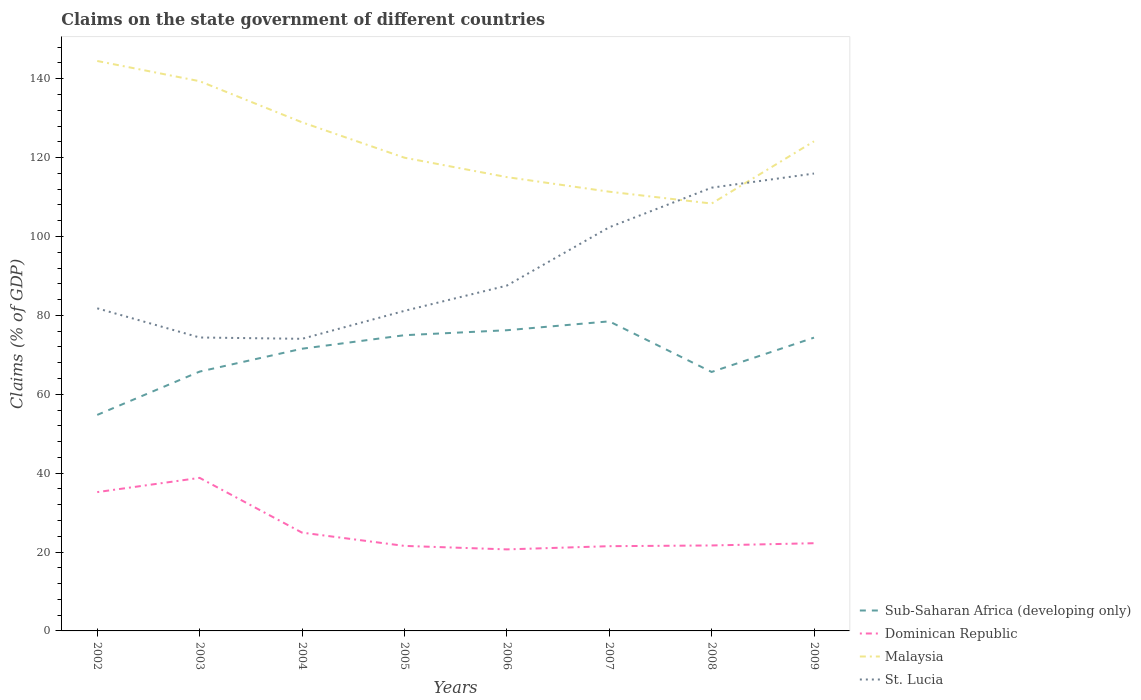Across all years, what is the maximum percentage of GDP claimed on the state government in St. Lucia?
Ensure brevity in your answer.  74.05. What is the total percentage of GDP claimed on the state government in Dominican Republic in the graph?
Give a very brief answer. 17.13. What is the difference between the highest and the second highest percentage of GDP claimed on the state government in Dominican Republic?
Offer a very short reply. 18.13. Is the percentage of GDP claimed on the state government in Sub-Saharan Africa (developing only) strictly greater than the percentage of GDP claimed on the state government in Dominican Republic over the years?
Provide a short and direct response. No. How many years are there in the graph?
Your answer should be compact. 8. Does the graph contain any zero values?
Give a very brief answer. No. Does the graph contain grids?
Your answer should be compact. No. Where does the legend appear in the graph?
Offer a terse response. Bottom right. How many legend labels are there?
Your answer should be compact. 4. What is the title of the graph?
Your answer should be very brief. Claims on the state government of different countries. What is the label or title of the X-axis?
Ensure brevity in your answer.  Years. What is the label or title of the Y-axis?
Make the answer very short. Claims (% of GDP). What is the Claims (% of GDP) in Sub-Saharan Africa (developing only) in 2002?
Your response must be concise. 54.76. What is the Claims (% of GDP) in Dominican Republic in 2002?
Give a very brief answer. 35.19. What is the Claims (% of GDP) in Malaysia in 2002?
Give a very brief answer. 144.49. What is the Claims (% of GDP) in St. Lucia in 2002?
Keep it short and to the point. 81.79. What is the Claims (% of GDP) in Sub-Saharan Africa (developing only) in 2003?
Provide a succinct answer. 65.75. What is the Claims (% of GDP) of Dominican Republic in 2003?
Ensure brevity in your answer.  38.8. What is the Claims (% of GDP) in Malaysia in 2003?
Offer a terse response. 139.37. What is the Claims (% of GDP) in St. Lucia in 2003?
Your answer should be very brief. 74.39. What is the Claims (% of GDP) of Sub-Saharan Africa (developing only) in 2004?
Your response must be concise. 71.54. What is the Claims (% of GDP) in Dominican Republic in 2004?
Ensure brevity in your answer.  24.92. What is the Claims (% of GDP) of Malaysia in 2004?
Make the answer very short. 128.94. What is the Claims (% of GDP) of St. Lucia in 2004?
Offer a very short reply. 74.05. What is the Claims (% of GDP) of Sub-Saharan Africa (developing only) in 2005?
Ensure brevity in your answer.  74.97. What is the Claims (% of GDP) of Dominican Republic in 2005?
Your answer should be compact. 21.56. What is the Claims (% of GDP) of Malaysia in 2005?
Provide a succinct answer. 119.97. What is the Claims (% of GDP) of St. Lucia in 2005?
Offer a very short reply. 81.14. What is the Claims (% of GDP) in Sub-Saharan Africa (developing only) in 2006?
Your answer should be compact. 76.23. What is the Claims (% of GDP) of Dominican Republic in 2006?
Provide a short and direct response. 20.67. What is the Claims (% of GDP) of Malaysia in 2006?
Make the answer very short. 115.05. What is the Claims (% of GDP) in St. Lucia in 2006?
Offer a terse response. 87.54. What is the Claims (% of GDP) in Sub-Saharan Africa (developing only) in 2007?
Give a very brief answer. 78.48. What is the Claims (% of GDP) in Dominican Republic in 2007?
Your answer should be very brief. 21.48. What is the Claims (% of GDP) in Malaysia in 2007?
Give a very brief answer. 111.35. What is the Claims (% of GDP) in St. Lucia in 2007?
Offer a terse response. 102.33. What is the Claims (% of GDP) in Sub-Saharan Africa (developing only) in 2008?
Offer a very short reply. 65.65. What is the Claims (% of GDP) of Dominican Republic in 2008?
Provide a short and direct response. 21.67. What is the Claims (% of GDP) of Malaysia in 2008?
Give a very brief answer. 108.35. What is the Claims (% of GDP) in St. Lucia in 2008?
Your response must be concise. 112.37. What is the Claims (% of GDP) of Sub-Saharan Africa (developing only) in 2009?
Keep it short and to the point. 74.35. What is the Claims (% of GDP) of Dominican Republic in 2009?
Keep it short and to the point. 22.24. What is the Claims (% of GDP) in Malaysia in 2009?
Provide a short and direct response. 124.12. What is the Claims (% of GDP) of St. Lucia in 2009?
Offer a very short reply. 115.96. Across all years, what is the maximum Claims (% of GDP) in Sub-Saharan Africa (developing only)?
Offer a terse response. 78.48. Across all years, what is the maximum Claims (% of GDP) of Dominican Republic?
Keep it short and to the point. 38.8. Across all years, what is the maximum Claims (% of GDP) in Malaysia?
Give a very brief answer. 144.49. Across all years, what is the maximum Claims (% of GDP) of St. Lucia?
Ensure brevity in your answer.  115.96. Across all years, what is the minimum Claims (% of GDP) in Sub-Saharan Africa (developing only)?
Offer a very short reply. 54.76. Across all years, what is the minimum Claims (% of GDP) of Dominican Republic?
Make the answer very short. 20.67. Across all years, what is the minimum Claims (% of GDP) in Malaysia?
Your answer should be very brief. 108.35. Across all years, what is the minimum Claims (% of GDP) of St. Lucia?
Provide a short and direct response. 74.05. What is the total Claims (% of GDP) in Sub-Saharan Africa (developing only) in the graph?
Your answer should be compact. 561.74. What is the total Claims (% of GDP) of Dominican Republic in the graph?
Your response must be concise. 206.52. What is the total Claims (% of GDP) in Malaysia in the graph?
Your response must be concise. 991.65. What is the total Claims (% of GDP) of St. Lucia in the graph?
Your answer should be very brief. 729.57. What is the difference between the Claims (% of GDP) in Sub-Saharan Africa (developing only) in 2002 and that in 2003?
Keep it short and to the point. -10.98. What is the difference between the Claims (% of GDP) of Dominican Republic in 2002 and that in 2003?
Offer a very short reply. -3.61. What is the difference between the Claims (% of GDP) of Malaysia in 2002 and that in 2003?
Your answer should be very brief. 5.12. What is the difference between the Claims (% of GDP) of St. Lucia in 2002 and that in 2003?
Offer a terse response. 7.4. What is the difference between the Claims (% of GDP) in Sub-Saharan Africa (developing only) in 2002 and that in 2004?
Keep it short and to the point. -16.78. What is the difference between the Claims (% of GDP) in Dominican Republic in 2002 and that in 2004?
Provide a succinct answer. 10.27. What is the difference between the Claims (% of GDP) of Malaysia in 2002 and that in 2004?
Your answer should be very brief. 15.54. What is the difference between the Claims (% of GDP) in St. Lucia in 2002 and that in 2004?
Provide a succinct answer. 7.73. What is the difference between the Claims (% of GDP) in Sub-Saharan Africa (developing only) in 2002 and that in 2005?
Keep it short and to the point. -20.21. What is the difference between the Claims (% of GDP) in Dominican Republic in 2002 and that in 2005?
Your answer should be compact. 13.64. What is the difference between the Claims (% of GDP) of Malaysia in 2002 and that in 2005?
Offer a very short reply. 24.52. What is the difference between the Claims (% of GDP) of St. Lucia in 2002 and that in 2005?
Provide a succinct answer. 0.64. What is the difference between the Claims (% of GDP) in Sub-Saharan Africa (developing only) in 2002 and that in 2006?
Offer a terse response. -21.47. What is the difference between the Claims (% of GDP) in Dominican Republic in 2002 and that in 2006?
Make the answer very short. 14.52. What is the difference between the Claims (% of GDP) of Malaysia in 2002 and that in 2006?
Offer a very short reply. 29.44. What is the difference between the Claims (% of GDP) in St. Lucia in 2002 and that in 2006?
Ensure brevity in your answer.  -5.76. What is the difference between the Claims (% of GDP) in Sub-Saharan Africa (developing only) in 2002 and that in 2007?
Provide a succinct answer. -23.72. What is the difference between the Claims (% of GDP) in Dominican Republic in 2002 and that in 2007?
Your answer should be very brief. 13.71. What is the difference between the Claims (% of GDP) in Malaysia in 2002 and that in 2007?
Your answer should be very brief. 33.13. What is the difference between the Claims (% of GDP) of St. Lucia in 2002 and that in 2007?
Provide a short and direct response. -20.54. What is the difference between the Claims (% of GDP) of Sub-Saharan Africa (developing only) in 2002 and that in 2008?
Your answer should be compact. -10.89. What is the difference between the Claims (% of GDP) in Dominican Republic in 2002 and that in 2008?
Your answer should be compact. 13.52. What is the difference between the Claims (% of GDP) in Malaysia in 2002 and that in 2008?
Provide a succinct answer. 36.14. What is the difference between the Claims (% of GDP) of St. Lucia in 2002 and that in 2008?
Keep it short and to the point. -30.58. What is the difference between the Claims (% of GDP) in Sub-Saharan Africa (developing only) in 2002 and that in 2009?
Give a very brief answer. -19.59. What is the difference between the Claims (% of GDP) of Dominican Republic in 2002 and that in 2009?
Give a very brief answer. 12.96. What is the difference between the Claims (% of GDP) in Malaysia in 2002 and that in 2009?
Give a very brief answer. 20.36. What is the difference between the Claims (% of GDP) in St. Lucia in 2002 and that in 2009?
Give a very brief answer. -34.17. What is the difference between the Claims (% of GDP) of Sub-Saharan Africa (developing only) in 2003 and that in 2004?
Provide a succinct answer. -5.8. What is the difference between the Claims (% of GDP) in Dominican Republic in 2003 and that in 2004?
Ensure brevity in your answer.  13.88. What is the difference between the Claims (% of GDP) of Malaysia in 2003 and that in 2004?
Give a very brief answer. 10.42. What is the difference between the Claims (% of GDP) in St. Lucia in 2003 and that in 2004?
Ensure brevity in your answer.  0.34. What is the difference between the Claims (% of GDP) in Sub-Saharan Africa (developing only) in 2003 and that in 2005?
Your answer should be very brief. -9.22. What is the difference between the Claims (% of GDP) of Dominican Republic in 2003 and that in 2005?
Your answer should be compact. 17.25. What is the difference between the Claims (% of GDP) in Malaysia in 2003 and that in 2005?
Your answer should be compact. 19.39. What is the difference between the Claims (% of GDP) of St. Lucia in 2003 and that in 2005?
Offer a very short reply. -6.75. What is the difference between the Claims (% of GDP) of Sub-Saharan Africa (developing only) in 2003 and that in 2006?
Offer a very short reply. -10.49. What is the difference between the Claims (% of GDP) in Dominican Republic in 2003 and that in 2006?
Your answer should be compact. 18.13. What is the difference between the Claims (% of GDP) of Malaysia in 2003 and that in 2006?
Give a very brief answer. 24.31. What is the difference between the Claims (% of GDP) in St. Lucia in 2003 and that in 2006?
Keep it short and to the point. -13.15. What is the difference between the Claims (% of GDP) of Sub-Saharan Africa (developing only) in 2003 and that in 2007?
Your response must be concise. -12.74. What is the difference between the Claims (% of GDP) of Dominican Republic in 2003 and that in 2007?
Provide a succinct answer. 17.32. What is the difference between the Claims (% of GDP) in Malaysia in 2003 and that in 2007?
Give a very brief answer. 28.01. What is the difference between the Claims (% of GDP) of St. Lucia in 2003 and that in 2007?
Ensure brevity in your answer.  -27.94. What is the difference between the Claims (% of GDP) in Sub-Saharan Africa (developing only) in 2003 and that in 2008?
Keep it short and to the point. 0.09. What is the difference between the Claims (% of GDP) of Dominican Republic in 2003 and that in 2008?
Ensure brevity in your answer.  17.13. What is the difference between the Claims (% of GDP) in Malaysia in 2003 and that in 2008?
Provide a succinct answer. 31.02. What is the difference between the Claims (% of GDP) of St. Lucia in 2003 and that in 2008?
Ensure brevity in your answer.  -37.98. What is the difference between the Claims (% of GDP) of Sub-Saharan Africa (developing only) in 2003 and that in 2009?
Your response must be concise. -8.61. What is the difference between the Claims (% of GDP) of Dominican Republic in 2003 and that in 2009?
Provide a short and direct response. 16.57. What is the difference between the Claims (% of GDP) in Malaysia in 2003 and that in 2009?
Provide a succinct answer. 15.24. What is the difference between the Claims (% of GDP) in St. Lucia in 2003 and that in 2009?
Provide a succinct answer. -41.56. What is the difference between the Claims (% of GDP) in Sub-Saharan Africa (developing only) in 2004 and that in 2005?
Offer a terse response. -3.43. What is the difference between the Claims (% of GDP) in Dominican Republic in 2004 and that in 2005?
Offer a terse response. 3.36. What is the difference between the Claims (% of GDP) in Malaysia in 2004 and that in 2005?
Your answer should be compact. 8.97. What is the difference between the Claims (% of GDP) in St. Lucia in 2004 and that in 2005?
Ensure brevity in your answer.  -7.09. What is the difference between the Claims (% of GDP) in Sub-Saharan Africa (developing only) in 2004 and that in 2006?
Keep it short and to the point. -4.69. What is the difference between the Claims (% of GDP) of Dominican Republic in 2004 and that in 2006?
Provide a short and direct response. 4.25. What is the difference between the Claims (% of GDP) of Malaysia in 2004 and that in 2006?
Make the answer very short. 13.89. What is the difference between the Claims (% of GDP) of St. Lucia in 2004 and that in 2006?
Ensure brevity in your answer.  -13.49. What is the difference between the Claims (% of GDP) of Sub-Saharan Africa (developing only) in 2004 and that in 2007?
Your answer should be very brief. -6.94. What is the difference between the Claims (% of GDP) in Dominican Republic in 2004 and that in 2007?
Provide a short and direct response. 3.44. What is the difference between the Claims (% of GDP) in Malaysia in 2004 and that in 2007?
Your answer should be very brief. 17.59. What is the difference between the Claims (% of GDP) in St. Lucia in 2004 and that in 2007?
Offer a terse response. -28.27. What is the difference between the Claims (% of GDP) of Sub-Saharan Africa (developing only) in 2004 and that in 2008?
Your response must be concise. 5.89. What is the difference between the Claims (% of GDP) in Dominican Republic in 2004 and that in 2008?
Make the answer very short. 3.25. What is the difference between the Claims (% of GDP) in Malaysia in 2004 and that in 2008?
Offer a very short reply. 20.59. What is the difference between the Claims (% of GDP) of St. Lucia in 2004 and that in 2008?
Provide a short and direct response. -38.32. What is the difference between the Claims (% of GDP) of Sub-Saharan Africa (developing only) in 2004 and that in 2009?
Give a very brief answer. -2.81. What is the difference between the Claims (% of GDP) of Dominican Republic in 2004 and that in 2009?
Your answer should be very brief. 2.68. What is the difference between the Claims (% of GDP) in Malaysia in 2004 and that in 2009?
Your answer should be very brief. 4.82. What is the difference between the Claims (% of GDP) in St. Lucia in 2004 and that in 2009?
Provide a short and direct response. -41.9. What is the difference between the Claims (% of GDP) of Sub-Saharan Africa (developing only) in 2005 and that in 2006?
Your answer should be very brief. -1.26. What is the difference between the Claims (% of GDP) in Dominican Republic in 2005 and that in 2006?
Ensure brevity in your answer.  0.89. What is the difference between the Claims (% of GDP) of Malaysia in 2005 and that in 2006?
Make the answer very short. 4.92. What is the difference between the Claims (% of GDP) of St. Lucia in 2005 and that in 2006?
Your answer should be very brief. -6.4. What is the difference between the Claims (% of GDP) of Sub-Saharan Africa (developing only) in 2005 and that in 2007?
Offer a terse response. -3.51. What is the difference between the Claims (% of GDP) of Dominican Republic in 2005 and that in 2007?
Offer a terse response. 0.07. What is the difference between the Claims (% of GDP) in Malaysia in 2005 and that in 2007?
Keep it short and to the point. 8.62. What is the difference between the Claims (% of GDP) of St. Lucia in 2005 and that in 2007?
Provide a succinct answer. -21.19. What is the difference between the Claims (% of GDP) in Sub-Saharan Africa (developing only) in 2005 and that in 2008?
Your response must be concise. 9.32. What is the difference between the Claims (% of GDP) in Dominican Republic in 2005 and that in 2008?
Your answer should be very brief. -0.11. What is the difference between the Claims (% of GDP) of Malaysia in 2005 and that in 2008?
Your response must be concise. 11.62. What is the difference between the Claims (% of GDP) in St. Lucia in 2005 and that in 2008?
Keep it short and to the point. -31.23. What is the difference between the Claims (% of GDP) in Sub-Saharan Africa (developing only) in 2005 and that in 2009?
Your answer should be compact. 0.62. What is the difference between the Claims (% of GDP) in Dominican Republic in 2005 and that in 2009?
Make the answer very short. -0.68. What is the difference between the Claims (% of GDP) in Malaysia in 2005 and that in 2009?
Offer a very short reply. -4.15. What is the difference between the Claims (% of GDP) in St. Lucia in 2005 and that in 2009?
Keep it short and to the point. -34.81. What is the difference between the Claims (% of GDP) of Sub-Saharan Africa (developing only) in 2006 and that in 2007?
Your answer should be compact. -2.25. What is the difference between the Claims (% of GDP) in Dominican Republic in 2006 and that in 2007?
Your response must be concise. -0.81. What is the difference between the Claims (% of GDP) in Malaysia in 2006 and that in 2007?
Offer a terse response. 3.7. What is the difference between the Claims (% of GDP) in St. Lucia in 2006 and that in 2007?
Offer a terse response. -14.78. What is the difference between the Claims (% of GDP) in Sub-Saharan Africa (developing only) in 2006 and that in 2008?
Provide a short and direct response. 10.58. What is the difference between the Claims (% of GDP) in Dominican Republic in 2006 and that in 2008?
Your answer should be very brief. -1. What is the difference between the Claims (% of GDP) of Malaysia in 2006 and that in 2008?
Ensure brevity in your answer.  6.7. What is the difference between the Claims (% of GDP) of St. Lucia in 2006 and that in 2008?
Provide a short and direct response. -24.83. What is the difference between the Claims (% of GDP) of Sub-Saharan Africa (developing only) in 2006 and that in 2009?
Offer a very short reply. 1.88. What is the difference between the Claims (% of GDP) of Dominican Republic in 2006 and that in 2009?
Your answer should be compact. -1.56. What is the difference between the Claims (% of GDP) of Malaysia in 2006 and that in 2009?
Offer a terse response. -9.07. What is the difference between the Claims (% of GDP) in St. Lucia in 2006 and that in 2009?
Offer a terse response. -28.41. What is the difference between the Claims (% of GDP) of Sub-Saharan Africa (developing only) in 2007 and that in 2008?
Make the answer very short. 12.83. What is the difference between the Claims (% of GDP) in Dominican Republic in 2007 and that in 2008?
Your answer should be compact. -0.18. What is the difference between the Claims (% of GDP) of Malaysia in 2007 and that in 2008?
Make the answer very short. 3. What is the difference between the Claims (% of GDP) in St. Lucia in 2007 and that in 2008?
Make the answer very short. -10.04. What is the difference between the Claims (% of GDP) of Sub-Saharan Africa (developing only) in 2007 and that in 2009?
Provide a succinct answer. 4.13. What is the difference between the Claims (% of GDP) of Dominican Republic in 2007 and that in 2009?
Offer a very short reply. -0.75. What is the difference between the Claims (% of GDP) in Malaysia in 2007 and that in 2009?
Your answer should be compact. -12.77. What is the difference between the Claims (% of GDP) in St. Lucia in 2007 and that in 2009?
Offer a terse response. -13.63. What is the difference between the Claims (% of GDP) of Sub-Saharan Africa (developing only) in 2008 and that in 2009?
Your response must be concise. -8.7. What is the difference between the Claims (% of GDP) of Dominican Republic in 2008 and that in 2009?
Keep it short and to the point. -0.57. What is the difference between the Claims (% of GDP) of Malaysia in 2008 and that in 2009?
Offer a very short reply. -15.77. What is the difference between the Claims (% of GDP) in St. Lucia in 2008 and that in 2009?
Offer a very short reply. -3.58. What is the difference between the Claims (% of GDP) of Sub-Saharan Africa (developing only) in 2002 and the Claims (% of GDP) of Dominican Republic in 2003?
Give a very brief answer. 15.96. What is the difference between the Claims (% of GDP) of Sub-Saharan Africa (developing only) in 2002 and the Claims (% of GDP) of Malaysia in 2003?
Your answer should be very brief. -84.6. What is the difference between the Claims (% of GDP) in Sub-Saharan Africa (developing only) in 2002 and the Claims (% of GDP) in St. Lucia in 2003?
Give a very brief answer. -19.63. What is the difference between the Claims (% of GDP) of Dominican Republic in 2002 and the Claims (% of GDP) of Malaysia in 2003?
Provide a succinct answer. -104.17. What is the difference between the Claims (% of GDP) of Dominican Republic in 2002 and the Claims (% of GDP) of St. Lucia in 2003?
Ensure brevity in your answer.  -39.2. What is the difference between the Claims (% of GDP) in Malaysia in 2002 and the Claims (% of GDP) in St. Lucia in 2003?
Your answer should be very brief. 70.1. What is the difference between the Claims (% of GDP) in Sub-Saharan Africa (developing only) in 2002 and the Claims (% of GDP) in Dominican Republic in 2004?
Ensure brevity in your answer.  29.84. What is the difference between the Claims (% of GDP) in Sub-Saharan Africa (developing only) in 2002 and the Claims (% of GDP) in Malaysia in 2004?
Give a very brief answer. -74.18. What is the difference between the Claims (% of GDP) of Sub-Saharan Africa (developing only) in 2002 and the Claims (% of GDP) of St. Lucia in 2004?
Make the answer very short. -19.29. What is the difference between the Claims (% of GDP) of Dominican Republic in 2002 and the Claims (% of GDP) of Malaysia in 2004?
Your response must be concise. -93.75. What is the difference between the Claims (% of GDP) of Dominican Republic in 2002 and the Claims (% of GDP) of St. Lucia in 2004?
Your answer should be compact. -38.86. What is the difference between the Claims (% of GDP) in Malaysia in 2002 and the Claims (% of GDP) in St. Lucia in 2004?
Keep it short and to the point. 70.43. What is the difference between the Claims (% of GDP) of Sub-Saharan Africa (developing only) in 2002 and the Claims (% of GDP) of Dominican Republic in 2005?
Give a very brief answer. 33.21. What is the difference between the Claims (% of GDP) of Sub-Saharan Africa (developing only) in 2002 and the Claims (% of GDP) of Malaysia in 2005?
Your answer should be compact. -65.21. What is the difference between the Claims (% of GDP) of Sub-Saharan Africa (developing only) in 2002 and the Claims (% of GDP) of St. Lucia in 2005?
Provide a succinct answer. -26.38. What is the difference between the Claims (% of GDP) in Dominican Republic in 2002 and the Claims (% of GDP) in Malaysia in 2005?
Your response must be concise. -84.78. What is the difference between the Claims (% of GDP) of Dominican Republic in 2002 and the Claims (% of GDP) of St. Lucia in 2005?
Offer a very short reply. -45.95. What is the difference between the Claims (% of GDP) in Malaysia in 2002 and the Claims (% of GDP) in St. Lucia in 2005?
Offer a very short reply. 63.35. What is the difference between the Claims (% of GDP) of Sub-Saharan Africa (developing only) in 2002 and the Claims (% of GDP) of Dominican Republic in 2006?
Provide a short and direct response. 34.09. What is the difference between the Claims (% of GDP) in Sub-Saharan Africa (developing only) in 2002 and the Claims (% of GDP) in Malaysia in 2006?
Give a very brief answer. -60.29. What is the difference between the Claims (% of GDP) in Sub-Saharan Africa (developing only) in 2002 and the Claims (% of GDP) in St. Lucia in 2006?
Your answer should be very brief. -32.78. What is the difference between the Claims (% of GDP) in Dominican Republic in 2002 and the Claims (% of GDP) in Malaysia in 2006?
Provide a short and direct response. -79.86. What is the difference between the Claims (% of GDP) of Dominican Republic in 2002 and the Claims (% of GDP) of St. Lucia in 2006?
Your answer should be very brief. -52.35. What is the difference between the Claims (% of GDP) of Malaysia in 2002 and the Claims (% of GDP) of St. Lucia in 2006?
Give a very brief answer. 56.94. What is the difference between the Claims (% of GDP) in Sub-Saharan Africa (developing only) in 2002 and the Claims (% of GDP) in Dominican Republic in 2007?
Keep it short and to the point. 33.28. What is the difference between the Claims (% of GDP) of Sub-Saharan Africa (developing only) in 2002 and the Claims (% of GDP) of Malaysia in 2007?
Ensure brevity in your answer.  -56.59. What is the difference between the Claims (% of GDP) in Sub-Saharan Africa (developing only) in 2002 and the Claims (% of GDP) in St. Lucia in 2007?
Your answer should be compact. -47.56. What is the difference between the Claims (% of GDP) of Dominican Republic in 2002 and the Claims (% of GDP) of Malaysia in 2007?
Ensure brevity in your answer.  -76.16. What is the difference between the Claims (% of GDP) of Dominican Republic in 2002 and the Claims (% of GDP) of St. Lucia in 2007?
Offer a very short reply. -67.14. What is the difference between the Claims (% of GDP) in Malaysia in 2002 and the Claims (% of GDP) in St. Lucia in 2007?
Keep it short and to the point. 42.16. What is the difference between the Claims (% of GDP) of Sub-Saharan Africa (developing only) in 2002 and the Claims (% of GDP) of Dominican Republic in 2008?
Make the answer very short. 33.1. What is the difference between the Claims (% of GDP) in Sub-Saharan Africa (developing only) in 2002 and the Claims (% of GDP) in Malaysia in 2008?
Ensure brevity in your answer.  -53.59. What is the difference between the Claims (% of GDP) in Sub-Saharan Africa (developing only) in 2002 and the Claims (% of GDP) in St. Lucia in 2008?
Ensure brevity in your answer.  -57.61. What is the difference between the Claims (% of GDP) in Dominican Republic in 2002 and the Claims (% of GDP) in Malaysia in 2008?
Make the answer very short. -73.16. What is the difference between the Claims (% of GDP) in Dominican Republic in 2002 and the Claims (% of GDP) in St. Lucia in 2008?
Make the answer very short. -77.18. What is the difference between the Claims (% of GDP) of Malaysia in 2002 and the Claims (% of GDP) of St. Lucia in 2008?
Ensure brevity in your answer.  32.12. What is the difference between the Claims (% of GDP) in Sub-Saharan Africa (developing only) in 2002 and the Claims (% of GDP) in Dominican Republic in 2009?
Your response must be concise. 32.53. What is the difference between the Claims (% of GDP) of Sub-Saharan Africa (developing only) in 2002 and the Claims (% of GDP) of Malaysia in 2009?
Keep it short and to the point. -69.36. What is the difference between the Claims (% of GDP) of Sub-Saharan Africa (developing only) in 2002 and the Claims (% of GDP) of St. Lucia in 2009?
Your answer should be very brief. -61.19. What is the difference between the Claims (% of GDP) in Dominican Republic in 2002 and the Claims (% of GDP) in Malaysia in 2009?
Provide a short and direct response. -88.93. What is the difference between the Claims (% of GDP) of Dominican Republic in 2002 and the Claims (% of GDP) of St. Lucia in 2009?
Make the answer very short. -80.76. What is the difference between the Claims (% of GDP) in Malaysia in 2002 and the Claims (% of GDP) in St. Lucia in 2009?
Keep it short and to the point. 28.53. What is the difference between the Claims (% of GDP) of Sub-Saharan Africa (developing only) in 2003 and the Claims (% of GDP) of Dominican Republic in 2004?
Offer a terse response. 40.83. What is the difference between the Claims (% of GDP) of Sub-Saharan Africa (developing only) in 2003 and the Claims (% of GDP) of Malaysia in 2004?
Your answer should be compact. -63.2. What is the difference between the Claims (% of GDP) in Sub-Saharan Africa (developing only) in 2003 and the Claims (% of GDP) in St. Lucia in 2004?
Keep it short and to the point. -8.31. What is the difference between the Claims (% of GDP) in Dominican Republic in 2003 and the Claims (% of GDP) in Malaysia in 2004?
Provide a short and direct response. -90.14. What is the difference between the Claims (% of GDP) in Dominican Republic in 2003 and the Claims (% of GDP) in St. Lucia in 2004?
Ensure brevity in your answer.  -35.25. What is the difference between the Claims (% of GDP) of Malaysia in 2003 and the Claims (% of GDP) of St. Lucia in 2004?
Give a very brief answer. 65.31. What is the difference between the Claims (% of GDP) in Sub-Saharan Africa (developing only) in 2003 and the Claims (% of GDP) in Dominican Republic in 2005?
Your answer should be very brief. 44.19. What is the difference between the Claims (% of GDP) in Sub-Saharan Africa (developing only) in 2003 and the Claims (% of GDP) in Malaysia in 2005?
Offer a very short reply. -54.23. What is the difference between the Claims (% of GDP) in Sub-Saharan Africa (developing only) in 2003 and the Claims (% of GDP) in St. Lucia in 2005?
Your answer should be very brief. -15.4. What is the difference between the Claims (% of GDP) in Dominican Republic in 2003 and the Claims (% of GDP) in Malaysia in 2005?
Make the answer very short. -81.17. What is the difference between the Claims (% of GDP) in Dominican Republic in 2003 and the Claims (% of GDP) in St. Lucia in 2005?
Provide a short and direct response. -42.34. What is the difference between the Claims (% of GDP) of Malaysia in 2003 and the Claims (% of GDP) of St. Lucia in 2005?
Offer a very short reply. 58.22. What is the difference between the Claims (% of GDP) in Sub-Saharan Africa (developing only) in 2003 and the Claims (% of GDP) in Dominican Republic in 2006?
Offer a very short reply. 45.08. What is the difference between the Claims (% of GDP) of Sub-Saharan Africa (developing only) in 2003 and the Claims (% of GDP) of Malaysia in 2006?
Provide a short and direct response. -49.31. What is the difference between the Claims (% of GDP) of Sub-Saharan Africa (developing only) in 2003 and the Claims (% of GDP) of St. Lucia in 2006?
Your response must be concise. -21.8. What is the difference between the Claims (% of GDP) of Dominican Republic in 2003 and the Claims (% of GDP) of Malaysia in 2006?
Offer a terse response. -76.25. What is the difference between the Claims (% of GDP) of Dominican Republic in 2003 and the Claims (% of GDP) of St. Lucia in 2006?
Make the answer very short. -48.74. What is the difference between the Claims (% of GDP) of Malaysia in 2003 and the Claims (% of GDP) of St. Lucia in 2006?
Your answer should be compact. 51.82. What is the difference between the Claims (% of GDP) in Sub-Saharan Africa (developing only) in 2003 and the Claims (% of GDP) in Dominican Republic in 2007?
Give a very brief answer. 44.26. What is the difference between the Claims (% of GDP) of Sub-Saharan Africa (developing only) in 2003 and the Claims (% of GDP) of Malaysia in 2007?
Give a very brief answer. -45.61. What is the difference between the Claims (% of GDP) in Sub-Saharan Africa (developing only) in 2003 and the Claims (% of GDP) in St. Lucia in 2007?
Provide a short and direct response. -36.58. What is the difference between the Claims (% of GDP) in Dominican Republic in 2003 and the Claims (% of GDP) in Malaysia in 2007?
Keep it short and to the point. -72.55. What is the difference between the Claims (% of GDP) of Dominican Republic in 2003 and the Claims (% of GDP) of St. Lucia in 2007?
Your answer should be very brief. -63.53. What is the difference between the Claims (% of GDP) in Malaysia in 2003 and the Claims (% of GDP) in St. Lucia in 2007?
Offer a very short reply. 37.04. What is the difference between the Claims (% of GDP) in Sub-Saharan Africa (developing only) in 2003 and the Claims (% of GDP) in Dominican Republic in 2008?
Your answer should be very brief. 44.08. What is the difference between the Claims (% of GDP) of Sub-Saharan Africa (developing only) in 2003 and the Claims (% of GDP) of Malaysia in 2008?
Ensure brevity in your answer.  -42.6. What is the difference between the Claims (% of GDP) in Sub-Saharan Africa (developing only) in 2003 and the Claims (% of GDP) in St. Lucia in 2008?
Offer a very short reply. -46.62. What is the difference between the Claims (% of GDP) in Dominican Republic in 2003 and the Claims (% of GDP) in Malaysia in 2008?
Your answer should be compact. -69.55. What is the difference between the Claims (% of GDP) of Dominican Republic in 2003 and the Claims (% of GDP) of St. Lucia in 2008?
Provide a succinct answer. -73.57. What is the difference between the Claims (% of GDP) of Malaysia in 2003 and the Claims (% of GDP) of St. Lucia in 2008?
Offer a very short reply. 27. What is the difference between the Claims (% of GDP) of Sub-Saharan Africa (developing only) in 2003 and the Claims (% of GDP) of Dominican Republic in 2009?
Provide a short and direct response. 43.51. What is the difference between the Claims (% of GDP) of Sub-Saharan Africa (developing only) in 2003 and the Claims (% of GDP) of Malaysia in 2009?
Your answer should be compact. -58.38. What is the difference between the Claims (% of GDP) of Sub-Saharan Africa (developing only) in 2003 and the Claims (% of GDP) of St. Lucia in 2009?
Provide a succinct answer. -50.21. What is the difference between the Claims (% of GDP) of Dominican Republic in 2003 and the Claims (% of GDP) of Malaysia in 2009?
Offer a very short reply. -85.32. What is the difference between the Claims (% of GDP) of Dominican Republic in 2003 and the Claims (% of GDP) of St. Lucia in 2009?
Your response must be concise. -77.15. What is the difference between the Claims (% of GDP) in Malaysia in 2003 and the Claims (% of GDP) in St. Lucia in 2009?
Offer a terse response. 23.41. What is the difference between the Claims (% of GDP) in Sub-Saharan Africa (developing only) in 2004 and the Claims (% of GDP) in Dominican Republic in 2005?
Provide a succinct answer. 49.99. What is the difference between the Claims (% of GDP) in Sub-Saharan Africa (developing only) in 2004 and the Claims (% of GDP) in Malaysia in 2005?
Provide a succinct answer. -48.43. What is the difference between the Claims (% of GDP) in Sub-Saharan Africa (developing only) in 2004 and the Claims (% of GDP) in St. Lucia in 2005?
Make the answer very short. -9.6. What is the difference between the Claims (% of GDP) of Dominican Republic in 2004 and the Claims (% of GDP) of Malaysia in 2005?
Provide a succinct answer. -95.05. What is the difference between the Claims (% of GDP) of Dominican Republic in 2004 and the Claims (% of GDP) of St. Lucia in 2005?
Ensure brevity in your answer.  -56.22. What is the difference between the Claims (% of GDP) of Malaysia in 2004 and the Claims (% of GDP) of St. Lucia in 2005?
Ensure brevity in your answer.  47.8. What is the difference between the Claims (% of GDP) of Sub-Saharan Africa (developing only) in 2004 and the Claims (% of GDP) of Dominican Republic in 2006?
Offer a very short reply. 50.87. What is the difference between the Claims (% of GDP) of Sub-Saharan Africa (developing only) in 2004 and the Claims (% of GDP) of Malaysia in 2006?
Provide a succinct answer. -43.51. What is the difference between the Claims (% of GDP) of Sub-Saharan Africa (developing only) in 2004 and the Claims (% of GDP) of St. Lucia in 2006?
Your response must be concise. -16. What is the difference between the Claims (% of GDP) of Dominican Republic in 2004 and the Claims (% of GDP) of Malaysia in 2006?
Give a very brief answer. -90.13. What is the difference between the Claims (% of GDP) of Dominican Republic in 2004 and the Claims (% of GDP) of St. Lucia in 2006?
Ensure brevity in your answer.  -62.62. What is the difference between the Claims (% of GDP) of Malaysia in 2004 and the Claims (% of GDP) of St. Lucia in 2006?
Provide a short and direct response. 41.4. What is the difference between the Claims (% of GDP) in Sub-Saharan Africa (developing only) in 2004 and the Claims (% of GDP) in Dominican Republic in 2007?
Offer a terse response. 50.06. What is the difference between the Claims (% of GDP) in Sub-Saharan Africa (developing only) in 2004 and the Claims (% of GDP) in Malaysia in 2007?
Offer a terse response. -39.81. What is the difference between the Claims (% of GDP) in Sub-Saharan Africa (developing only) in 2004 and the Claims (% of GDP) in St. Lucia in 2007?
Your answer should be compact. -30.79. What is the difference between the Claims (% of GDP) in Dominican Republic in 2004 and the Claims (% of GDP) in Malaysia in 2007?
Your response must be concise. -86.43. What is the difference between the Claims (% of GDP) in Dominican Republic in 2004 and the Claims (% of GDP) in St. Lucia in 2007?
Ensure brevity in your answer.  -77.41. What is the difference between the Claims (% of GDP) of Malaysia in 2004 and the Claims (% of GDP) of St. Lucia in 2007?
Give a very brief answer. 26.62. What is the difference between the Claims (% of GDP) of Sub-Saharan Africa (developing only) in 2004 and the Claims (% of GDP) of Dominican Republic in 2008?
Keep it short and to the point. 49.87. What is the difference between the Claims (% of GDP) in Sub-Saharan Africa (developing only) in 2004 and the Claims (% of GDP) in Malaysia in 2008?
Make the answer very short. -36.81. What is the difference between the Claims (% of GDP) of Sub-Saharan Africa (developing only) in 2004 and the Claims (% of GDP) of St. Lucia in 2008?
Your response must be concise. -40.83. What is the difference between the Claims (% of GDP) in Dominican Republic in 2004 and the Claims (% of GDP) in Malaysia in 2008?
Offer a terse response. -83.43. What is the difference between the Claims (% of GDP) in Dominican Republic in 2004 and the Claims (% of GDP) in St. Lucia in 2008?
Ensure brevity in your answer.  -87.45. What is the difference between the Claims (% of GDP) in Malaysia in 2004 and the Claims (% of GDP) in St. Lucia in 2008?
Provide a short and direct response. 16.57. What is the difference between the Claims (% of GDP) of Sub-Saharan Africa (developing only) in 2004 and the Claims (% of GDP) of Dominican Republic in 2009?
Give a very brief answer. 49.31. What is the difference between the Claims (% of GDP) of Sub-Saharan Africa (developing only) in 2004 and the Claims (% of GDP) of Malaysia in 2009?
Make the answer very short. -52.58. What is the difference between the Claims (% of GDP) in Sub-Saharan Africa (developing only) in 2004 and the Claims (% of GDP) in St. Lucia in 2009?
Keep it short and to the point. -44.41. What is the difference between the Claims (% of GDP) of Dominican Republic in 2004 and the Claims (% of GDP) of Malaysia in 2009?
Provide a short and direct response. -99.2. What is the difference between the Claims (% of GDP) of Dominican Republic in 2004 and the Claims (% of GDP) of St. Lucia in 2009?
Your answer should be very brief. -91.04. What is the difference between the Claims (% of GDP) in Malaysia in 2004 and the Claims (% of GDP) in St. Lucia in 2009?
Offer a very short reply. 12.99. What is the difference between the Claims (% of GDP) in Sub-Saharan Africa (developing only) in 2005 and the Claims (% of GDP) in Dominican Republic in 2006?
Your answer should be compact. 54.3. What is the difference between the Claims (% of GDP) of Sub-Saharan Africa (developing only) in 2005 and the Claims (% of GDP) of Malaysia in 2006?
Ensure brevity in your answer.  -40.08. What is the difference between the Claims (% of GDP) of Sub-Saharan Africa (developing only) in 2005 and the Claims (% of GDP) of St. Lucia in 2006?
Give a very brief answer. -12.57. What is the difference between the Claims (% of GDP) in Dominican Republic in 2005 and the Claims (% of GDP) in Malaysia in 2006?
Your answer should be compact. -93.5. What is the difference between the Claims (% of GDP) in Dominican Republic in 2005 and the Claims (% of GDP) in St. Lucia in 2006?
Your answer should be very brief. -65.99. What is the difference between the Claims (% of GDP) in Malaysia in 2005 and the Claims (% of GDP) in St. Lucia in 2006?
Your response must be concise. 32.43. What is the difference between the Claims (% of GDP) in Sub-Saharan Africa (developing only) in 2005 and the Claims (% of GDP) in Dominican Republic in 2007?
Offer a very short reply. 53.49. What is the difference between the Claims (% of GDP) of Sub-Saharan Africa (developing only) in 2005 and the Claims (% of GDP) of Malaysia in 2007?
Offer a very short reply. -36.38. What is the difference between the Claims (% of GDP) in Sub-Saharan Africa (developing only) in 2005 and the Claims (% of GDP) in St. Lucia in 2007?
Your response must be concise. -27.36. What is the difference between the Claims (% of GDP) in Dominican Republic in 2005 and the Claims (% of GDP) in Malaysia in 2007?
Provide a short and direct response. -89.8. What is the difference between the Claims (% of GDP) in Dominican Republic in 2005 and the Claims (% of GDP) in St. Lucia in 2007?
Make the answer very short. -80.77. What is the difference between the Claims (% of GDP) in Malaysia in 2005 and the Claims (% of GDP) in St. Lucia in 2007?
Offer a very short reply. 17.64. What is the difference between the Claims (% of GDP) in Sub-Saharan Africa (developing only) in 2005 and the Claims (% of GDP) in Dominican Republic in 2008?
Your answer should be very brief. 53.3. What is the difference between the Claims (% of GDP) in Sub-Saharan Africa (developing only) in 2005 and the Claims (% of GDP) in Malaysia in 2008?
Your answer should be very brief. -33.38. What is the difference between the Claims (% of GDP) in Sub-Saharan Africa (developing only) in 2005 and the Claims (% of GDP) in St. Lucia in 2008?
Your response must be concise. -37.4. What is the difference between the Claims (% of GDP) in Dominican Republic in 2005 and the Claims (% of GDP) in Malaysia in 2008?
Keep it short and to the point. -86.8. What is the difference between the Claims (% of GDP) of Dominican Republic in 2005 and the Claims (% of GDP) of St. Lucia in 2008?
Give a very brief answer. -90.81. What is the difference between the Claims (% of GDP) in Malaysia in 2005 and the Claims (% of GDP) in St. Lucia in 2008?
Your answer should be very brief. 7.6. What is the difference between the Claims (% of GDP) in Sub-Saharan Africa (developing only) in 2005 and the Claims (% of GDP) in Dominican Republic in 2009?
Ensure brevity in your answer.  52.74. What is the difference between the Claims (% of GDP) of Sub-Saharan Africa (developing only) in 2005 and the Claims (% of GDP) of Malaysia in 2009?
Ensure brevity in your answer.  -49.15. What is the difference between the Claims (% of GDP) in Sub-Saharan Africa (developing only) in 2005 and the Claims (% of GDP) in St. Lucia in 2009?
Offer a very short reply. -40.98. What is the difference between the Claims (% of GDP) of Dominican Republic in 2005 and the Claims (% of GDP) of Malaysia in 2009?
Provide a succinct answer. -102.57. What is the difference between the Claims (% of GDP) in Dominican Republic in 2005 and the Claims (% of GDP) in St. Lucia in 2009?
Your response must be concise. -94.4. What is the difference between the Claims (% of GDP) in Malaysia in 2005 and the Claims (% of GDP) in St. Lucia in 2009?
Your answer should be very brief. 4.02. What is the difference between the Claims (% of GDP) in Sub-Saharan Africa (developing only) in 2006 and the Claims (% of GDP) in Dominican Republic in 2007?
Give a very brief answer. 54.75. What is the difference between the Claims (% of GDP) of Sub-Saharan Africa (developing only) in 2006 and the Claims (% of GDP) of Malaysia in 2007?
Provide a short and direct response. -35.12. What is the difference between the Claims (% of GDP) in Sub-Saharan Africa (developing only) in 2006 and the Claims (% of GDP) in St. Lucia in 2007?
Offer a terse response. -26.1. What is the difference between the Claims (% of GDP) in Dominican Republic in 2006 and the Claims (% of GDP) in Malaysia in 2007?
Your answer should be very brief. -90.68. What is the difference between the Claims (% of GDP) in Dominican Republic in 2006 and the Claims (% of GDP) in St. Lucia in 2007?
Keep it short and to the point. -81.66. What is the difference between the Claims (% of GDP) in Malaysia in 2006 and the Claims (% of GDP) in St. Lucia in 2007?
Provide a short and direct response. 12.73. What is the difference between the Claims (% of GDP) in Sub-Saharan Africa (developing only) in 2006 and the Claims (% of GDP) in Dominican Republic in 2008?
Your answer should be very brief. 54.56. What is the difference between the Claims (% of GDP) of Sub-Saharan Africa (developing only) in 2006 and the Claims (% of GDP) of Malaysia in 2008?
Give a very brief answer. -32.12. What is the difference between the Claims (% of GDP) of Sub-Saharan Africa (developing only) in 2006 and the Claims (% of GDP) of St. Lucia in 2008?
Your response must be concise. -36.14. What is the difference between the Claims (% of GDP) of Dominican Republic in 2006 and the Claims (% of GDP) of Malaysia in 2008?
Your answer should be very brief. -87.68. What is the difference between the Claims (% of GDP) of Dominican Republic in 2006 and the Claims (% of GDP) of St. Lucia in 2008?
Ensure brevity in your answer.  -91.7. What is the difference between the Claims (% of GDP) of Malaysia in 2006 and the Claims (% of GDP) of St. Lucia in 2008?
Your answer should be very brief. 2.68. What is the difference between the Claims (% of GDP) of Sub-Saharan Africa (developing only) in 2006 and the Claims (% of GDP) of Dominican Republic in 2009?
Make the answer very short. 54. What is the difference between the Claims (% of GDP) in Sub-Saharan Africa (developing only) in 2006 and the Claims (% of GDP) in Malaysia in 2009?
Make the answer very short. -47.89. What is the difference between the Claims (% of GDP) of Sub-Saharan Africa (developing only) in 2006 and the Claims (% of GDP) of St. Lucia in 2009?
Offer a terse response. -39.72. What is the difference between the Claims (% of GDP) of Dominican Republic in 2006 and the Claims (% of GDP) of Malaysia in 2009?
Give a very brief answer. -103.45. What is the difference between the Claims (% of GDP) of Dominican Republic in 2006 and the Claims (% of GDP) of St. Lucia in 2009?
Give a very brief answer. -95.28. What is the difference between the Claims (% of GDP) in Malaysia in 2006 and the Claims (% of GDP) in St. Lucia in 2009?
Give a very brief answer. -0.9. What is the difference between the Claims (% of GDP) in Sub-Saharan Africa (developing only) in 2007 and the Claims (% of GDP) in Dominican Republic in 2008?
Your answer should be compact. 56.81. What is the difference between the Claims (% of GDP) in Sub-Saharan Africa (developing only) in 2007 and the Claims (% of GDP) in Malaysia in 2008?
Keep it short and to the point. -29.87. What is the difference between the Claims (% of GDP) in Sub-Saharan Africa (developing only) in 2007 and the Claims (% of GDP) in St. Lucia in 2008?
Offer a terse response. -33.89. What is the difference between the Claims (% of GDP) of Dominican Republic in 2007 and the Claims (% of GDP) of Malaysia in 2008?
Make the answer very short. -86.87. What is the difference between the Claims (% of GDP) of Dominican Republic in 2007 and the Claims (% of GDP) of St. Lucia in 2008?
Ensure brevity in your answer.  -90.89. What is the difference between the Claims (% of GDP) in Malaysia in 2007 and the Claims (% of GDP) in St. Lucia in 2008?
Provide a short and direct response. -1.02. What is the difference between the Claims (% of GDP) in Sub-Saharan Africa (developing only) in 2007 and the Claims (% of GDP) in Dominican Republic in 2009?
Provide a succinct answer. 56.25. What is the difference between the Claims (% of GDP) in Sub-Saharan Africa (developing only) in 2007 and the Claims (% of GDP) in Malaysia in 2009?
Offer a terse response. -45.64. What is the difference between the Claims (% of GDP) of Sub-Saharan Africa (developing only) in 2007 and the Claims (% of GDP) of St. Lucia in 2009?
Offer a terse response. -37.47. What is the difference between the Claims (% of GDP) in Dominican Republic in 2007 and the Claims (% of GDP) in Malaysia in 2009?
Provide a short and direct response. -102.64. What is the difference between the Claims (% of GDP) of Dominican Republic in 2007 and the Claims (% of GDP) of St. Lucia in 2009?
Offer a terse response. -94.47. What is the difference between the Claims (% of GDP) of Malaysia in 2007 and the Claims (% of GDP) of St. Lucia in 2009?
Your answer should be compact. -4.6. What is the difference between the Claims (% of GDP) in Sub-Saharan Africa (developing only) in 2008 and the Claims (% of GDP) in Dominican Republic in 2009?
Ensure brevity in your answer.  43.42. What is the difference between the Claims (% of GDP) in Sub-Saharan Africa (developing only) in 2008 and the Claims (% of GDP) in Malaysia in 2009?
Provide a short and direct response. -58.47. What is the difference between the Claims (% of GDP) in Sub-Saharan Africa (developing only) in 2008 and the Claims (% of GDP) in St. Lucia in 2009?
Make the answer very short. -50.3. What is the difference between the Claims (% of GDP) of Dominican Republic in 2008 and the Claims (% of GDP) of Malaysia in 2009?
Ensure brevity in your answer.  -102.46. What is the difference between the Claims (% of GDP) of Dominican Republic in 2008 and the Claims (% of GDP) of St. Lucia in 2009?
Your answer should be very brief. -94.29. What is the difference between the Claims (% of GDP) of Malaysia in 2008 and the Claims (% of GDP) of St. Lucia in 2009?
Keep it short and to the point. -7.6. What is the average Claims (% of GDP) in Sub-Saharan Africa (developing only) per year?
Your response must be concise. 70.22. What is the average Claims (% of GDP) of Dominican Republic per year?
Give a very brief answer. 25.82. What is the average Claims (% of GDP) of Malaysia per year?
Your answer should be very brief. 123.96. What is the average Claims (% of GDP) of St. Lucia per year?
Offer a terse response. 91.2. In the year 2002, what is the difference between the Claims (% of GDP) in Sub-Saharan Africa (developing only) and Claims (% of GDP) in Dominican Republic?
Make the answer very short. 19.57. In the year 2002, what is the difference between the Claims (% of GDP) in Sub-Saharan Africa (developing only) and Claims (% of GDP) in Malaysia?
Your response must be concise. -89.72. In the year 2002, what is the difference between the Claims (% of GDP) in Sub-Saharan Africa (developing only) and Claims (% of GDP) in St. Lucia?
Your answer should be compact. -27.02. In the year 2002, what is the difference between the Claims (% of GDP) of Dominican Republic and Claims (% of GDP) of Malaysia?
Ensure brevity in your answer.  -109.3. In the year 2002, what is the difference between the Claims (% of GDP) in Dominican Republic and Claims (% of GDP) in St. Lucia?
Keep it short and to the point. -46.59. In the year 2002, what is the difference between the Claims (% of GDP) of Malaysia and Claims (% of GDP) of St. Lucia?
Provide a short and direct response. 62.7. In the year 2003, what is the difference between the Claims (% of GDP) in Sub-Saharan Africa (developing only) and Claims (% of GDP) in Dominican Republic?
Offer a terse response. 26.94. In the year 2003, what is the difference between the Claims (% of GDP) in Sub-Saharan Africa (developing only) and Claims (% of GDP) in Malaysia?
Give a very brief answer. -73.62. In the year 2003, what is the difference between the Claims (% of GDP) of Sub-Saharan Africa (developing only) and Claims (% of GDP) of St. Lucia?
Provide a succinct answer. -8.64. In the year 2003, what is the difference between the Claims (% of GDP) in Dominican Republic and Claims (% of GDP) in Malaysia?
Your answer should be very brief. -100.56. In the year 2003, what is the difference between the Claims (% of GDP) in Dominican Republic and Claims (% of GDP) in St. Lucia?
Keep it short and to the point. -35.59. In the year 2003, what is the difference between the Claims (% of GDP) of Malaysia and Claims (% of GDP) of St. Lucia?
Give a very brief answer. 64.98. In the year 2004, what is the difference between the Claims (% of GDP) of Sub-Saharan Africa (developing only) and Claims (% of GDP) of Dominican Republic?
Ensure brevity in your answer.  46.62. In the year 2004, what is the difference between the Claims (% of GDP) of Sub-Saharan Africa (developing only) and Claims (% of GDP) of Malaysia?
Keep it short and to the point. -57.4. In the year 2004, what is the difference between the Claims (% of GDP) in Sub-Saharan Africa (developing only) and Claims (% of GDP) in St. Lucia?
Offer a terse response. -2.51. In the year 2004, what is the difference between the Claims (% of GDP) in Dominican Republic and Claims (% of GDP) in Malaysia?
Provide a short and direct response. -104.02. In the year 2004, what is the difference between the Claims (% of GDP) in Dominican Republic and Claims (% of GDP) in St. Lucia?
Your answer should be compact. -49.13. In the year 2004, what is the difference between the Claims (% of GDP) in Malaysia and Claims (% of GDP) in St. Lucia?
Give a very brief answer. 54.89. In the year 2005, what is the difference between the Claims (% of GDP) of Sub-Saharan Africa (developing only) and Claims (% of GDP) of Dominican Republic?
Your answer should be very brief. 53.41. In the year 2005, what is the difference between the Claims (% of GDP) in Sub-Saharan Africa (developing only) and Claims (% of GDP) in Malaysia?
Your answer should be very brief. -45. In the year 2005, what is the difference between the Claims (% of GDP) of Sub-Saharan Africa (developing only) and Claims (% of GDP) of St. Lucia?
Your response must be concise. -6.17. In the year 2005, what is the difference between the Claims (% of GDP) in Dominican Republic and Claims (% of GDP) in Malaysia?
Offer a very short reply. -98.42. In the year 2005, what is the difference between the Claims (% of GDP) in Dominican Republic and Claims (% of GDP) in St. Lucia?
Make the answer very short. -59.59. In the year 2005, what is the difference between the Claims (% of GDP) of Malaysia and Claims (% of GDP) of St. Lucia?
Keep it short and to the point. 38.83. In the year 2006, what is the difference between the Claims (% of GDP) in Sub-Saharan Africa (developing only) and Claims (% of GDP) in Dominican Republic?
Offer a very short reply. 55.56. In the year 2006, what is the difference between the Claims (% of GDP) in Sub-Saharan Africa (developing only) and Claims (% of GDP) in Malaysia?
Offer a very short reply. -38.82. In the year 2006, what is the difference between the Claims (% of GDP) in Sub-Saharan Africa (developing only) and Claims (% of GDP) in St. Lucia?
Keep it short and to the point. -11.31. In the year 2006, what is the difference between the Claims (% of GDP) in Dominican Republic and Claims (% of GDP) in Malaysia?
Your response must be concise. -94.38. In the year 2006, what is the difference between the Claims (% of GDP) in Dominican Republic and Claims (% of GDP) in St. Lucia?
Offer a terse response. -66.87. In the year 2006, what is the difference between the Claims (% of GDP) in Malaysia and Claims (% of GDP) in St. Lucia?
Offer a terse response. 27.51. In the year 2007, what is the difference between the Claims (% of GDP) in Sub-Saharan Africa (developing only) and Claims (% of GDP) in Dominican Republic?
Your response must be concise. 57. In the year 2007, what is the difference between the Claims (% of GDP) of Sub-Saharan Africa (developing only) and Claims (% of GDP) of Malaysia?
Make the answer very short. -32.87. In the year 2007, what is the difference between the Claims (% of GDP) in Sub-Saharan Africa (developing only) and Claims (% of GDP) in St. Lucia?
Make the answer very short. -23.85. In the year 2007, what is the difference between the Claims (% of GDP) of Dominican Republic and Claims (% of GDP) of Malaysia?
Your answer should be very brief. -89.87. In the year 2007, what is the difference between the Claims (% of GDP) in Dominican Republic and Claims (% of GDP) in St. Lucia?
Provide a succinct answer. -80.84. In the year 2007, what is the difference between the Claims (% of GDP) in Malaysia and Claims (% of GDP) in St. Lucia?
Offer a very short reply. 9.03. In the year 2008, what is the difference between the Claims (% of GDP) of Sub-Saharan Africa (developing only) and Claims (% of GDP) of Dominican Republic?
Give a very brief answer. 43.98. In the year 2008, what is the difference between the Claims (% of GDP) of Sub-Saharan Africa (developing only) and Claims (% of GDP) of Malaysia?
Ensure brevity in your answer.  -42.7. In the year 2008, what is the difference between the Claims (% of GDP) in Sub-Saharan Africa (developing only) and Claims (% of GDP) in St. Lucia?
Keep it short and to the point. -46.72. In the year 2008, what is the difference between the Claims (% of GDP) of Dominican Republic and Claims (% of GDP) of Malaysia?
Keep it short and to the point. -86.68. In the year 2008, what is the difference between the Claims (% of GDP) of Dominican Republic and Claims (% of GDP) of St. Lucia?
Ensure brevity in your answer.  -90.7. In the year 2008, what is the difference between the Claims (% of GDP) in Malaysia and Claims (% of GDP) in St. Lucia?
Provide a succinct answer. -4.02. In the year 2009, what is the difference between the Claims (% of GDP) in Sub-Saharan Africa (developing only) and Claims (% of GDP) in Dominican Republic?
Your response must be concise. 52.12. In the year 2009, what is the difference between the Claims (% of GDP) of Sub-Saharan Africa (developing only) and Claims (% of GDP) of Malaysia?
Your response must be concise. -49.77. In the year 2009, what is the difference between the Claims (% of GDP) of Sub-Saharan Africa (developing only) and Claims (% of GDP) of St. Lucia?
Offer a very short reply. -41.6. In the year 2009, what is the difference between the Claims (% of GDP) in Dominican Republic and Claims (% of GDP) in Malaysia?
Your answer should be compact. -101.89. In the year 2009, what is the difference between the Claims (% of GDP) of Dominican Republic and Claims (% of GDP) of St. Lucia?
Your answer should be very brief. -93.72. In the year 2009, what is the difference between the Claims (% of GDP) of Malaysia and Claims (% of GDP) of St. Lucia?
Provide a succinct answer. 8.17. What is the ratio of the Claims (% of GDP) of Sub-Saharan Africa (developing only) in 2002 to that in 2003?
Provide a succinct answer. 0.83. What is the ratio of the Claims (% of GDP) in Dominican Republic in 2002 to that in 2003?
Give a very brief answer. 0.91. What is the ratio of the Claims (% of GDP) in Malaysia in 2002 to that in 2003?
Ensure brevity in your answer.  1.04. What is the ratio of the Claims (% of GDP) in St. Lucia in 2002 to that in 2003?
Your answer should be very brief. 1.1. What is the ratio of the Claims (% of GDP) of Sub-Saharan Africa (developing only) in 2002 to that in 2004?
Ensure brevity in your answer.  0.77. What is the ratio of the Claims (% of GDP) in Dominican Republic in 2002 to that in 2004?
Give a very brief answer. 1.41. What is the ratio of the Claims (% of GDP) of Malaysia in 2002 to that in 2004?
Your response must be concise. 1.12. What is the ratio of the Claims (% of GDP) in St. Lucia in 2002 to that in 2004?
Keep it short and to the point. 1.1. What is the ratio of the Claims (% of GDP) of Sub-Saharan Africa (developing only) in 2002 to that in 2005?
Give a very brief answer. 0.73. What is the ratio of the Claims (% of GDP) of Dominican Republic in 2002 to that in 2005?
Give a very brief answer. 1.63. What is the ratio of the Claims (% of GDP) in Malaysia in 2002 to that in 2005?
Your answer should be compact. 1.2. What is the ratio of the Claims (% of GDP) of St. Lucia in 2002 to that in 2005?
Give a very brief answer. 1.01. What is the ratio of the Claims (% of GDP) in Sub-Saharan Africa (developing only) in 2002 to that in 2006?
Offer a very short reply. 0.72. What is the ratio of the Claims (% of GDP) in Dominican Republic in 2002 to that in 2006?
Give a very brief answer. 1.7. What is the ratio of the Claims (% of GDP) in Malaysia in 2002 to that in 2006?
Give a very brief answer. 1.26. What is the ratio of the Claims (% of GDP) in St. Lucia in 2002 to that in 2006?
Offer a very short reply. 0.93. What is the ratio of the Claims (% of GDP) of Sub-Saharan Africa (developing only) in 2002 to that in 2007?
Your response must be concise. 0.7. What is the ratio of the Claims (% of GDP) in Dominican Republic in 2002 to that in 2007?
Offer a terse response. 1.64. What is the ratio of the Claims (% of GDP) in Malaysia in 2002 to that in 2007?
Ensure brevity in your answer.  1.3. What is the ratio of the Claims (% of GDP) of St. Lucia in 2002 to that in 2007?
Ensure brevity in your answer.  0.8. What is the ratio of the Claims (% of GDP) in Sub-Saharan Africa (developing only) in 2002 to that in 2008?
Your answer should be very brief. 0.83. What is the ratio of the Claims (% of GDP) of Dominican Republic in 2002 to that in 2008?
Your answer should be very brief. 1.62. What is the ratio of the Claims (% of GDP) in Malaysia in 2002 to that in 2008?
Ensure brevity in your answer.  1.33. What is the ratio of the Claims (% of GDP) of St. Lucia in 2002 to that in 2008?
Keep it short and to the point. 0.73. What is the ratio of the Claims (% of GDP) of Sub-Saharan Africa (developing only) in 2002 to that in 2009?
Offer a terse response. 0.74. What is the ratio of the Claims (% of GDP) in Dominican Republic in 2002 to that in 2009?
Give a very brief answer. 1.58. What is the ratio of the Claims (% of GDP) in Malaysia in 2002 to that in 2009?
Keep it short and to the point. 1.16. What is the ratio of the Claims (% of GDP) of St. Lucia in 2002 to that in 2009?
Ensure brevity in your answer.  0.71. What is the ratio of the Claims (% of GDP) in Sub-Saharan Africa (developing only) in 2003 to that in 2004?
Offer a terse response. 0.92. What is the ratio of the Claims (% of GDP) in Dominican Republic in 2003 to that in 2004?
Provide a short and direct response. 1.56. What is the ratio of the Claims (% of GDP) in Malaysia in 2003 to that in 2004?
Ensure brevity in your answer.  1.08. What is the ratio of the Claims (% of GDP) in Sub-Saharan Africa (developing only) in 2003 to that in 2005?
Your answer should be compact. 0.88. What is the ratio of the Claims (% of GDP) in Dominican Republic in 2003 to that in 2005?
Your response must be concise. 1.8. What is the ratio of the Claims (% of GDP) of Malaysia in 2003 to that in 2005?
Offer a terse response. 1.16. What is the ratio of the Claims (% of GDP) in St. Lucia in 2003 to that in 2005?
Give a very brief answer. 0.92. What is the ratio of the Claims (% of GDP) of Sub-Saharan Africa (developing only) in 2003 to that in 2006?
Provide a succinct answer. 0.86. What is the ratio of the Claims (% of GDP) of Dominican Republic in 2003 to that in 2006?
Keep it short and to the point. 1.88. What is the ratio of the Claims (% of GDP) in Malaysia in 2003 to that in 2006?
Ensure brevity in your answer.  1.21. What is the ratio of the Claims (% of GDP) of St. Lucia in 2003 to that in 2006?
Give a very brief answer. 0.85. What is the ratio of the Claims (% of GDP) in Sub-Saharan Africa (developing only) in 2003 to that in 2007?
Keep it short and to the point. 0.84. What is the ratio of the Claims (% of GDP) of Dominican Republic in 2003 to that in 2007?
Your answer should be compact. 1.81. What is the ratio of the Claims (% of GDP) in Malaysia in 2003 to that in 2007?
Provide a short and direct response. 1.25. What is the ratio of the Claims (% of GDP) in St. Lucia in 2003 to that in 2007?
Your answer should be compact. 0.73. What is the ratio of the Claims (% of GDP) of Sub-Saharan Africa (developing only) in 2003 to that in 2008?
Offer a terse response. 1. What is the ratio of the Claims (% of GDP) in Dominican Republic in 2003 to that in 2008?
Your answer should be very brief. 1.79. What is the ratio of the Claims (% of GDP) in Malaysia in 2003 to that in 2008?
Your answer should be very brief. 1.29. What is the ratio of the Claims (% of GDP) of St. Lucia in 2003 to that in 2008?
Your response must be concise. 0.66. What is the ratio of the Claims (% of GDP) in Sub-Saharan Africa (developing only) in 2003 to that in 2009?
Offer a terse response. 0.88. What is the ratio of the Claims (% of GDP) of Dominican Republic in 2003 to that in 2009?
Your answer should be compact. 1.75. What is the ratio of the Claims (% of GDP) of Malaysia in 2003 to that in 2009?
Offer a very short reply. 1.12. What is the ratio of the Claims (% of GDP) of St. Lucia in 2003 to that in 2009?
Provide a short and direct response. 0.64. What is the ratio of the Claims (% of GDP) in Sub-Saharan Africa (developing only) in 2004 to that in 2005?
Your answer should be very brief. 0.95. What is the ratio of the Claims (% of GDP) of Dominican Republic in 2004 to that in 2005?
Offer a very short reply. 1.16. What is the ratio of the Claims (% of GDP) in Malaysia in 2004 to that in 2005?
Give a very brief answer. 1.07. What is the ratio of the Claims (% of GDP) in St. Lucia in 2004 to that in 2005?
Provide a short and direct response. 0.91. What is the ratio of the Claims (% of GDP) in Sub-Saharan Africa (developing only) in 2004 to that in 2006?
Your answer should be very brief. 0.94. What is the ratio of the Claims (% of GDP) of Dominican Republic in 2004 to that in 2006?
Provide a short and direct response. 1.21. What is the ratio of the Claims (% of GDP) in Malaysia in 2004 to that in 2006?
Offer a very short reply. 1.12. What is the ratio of the Claims (% of GDP) in St. Lucia in 2004 to that in 2006?
Your response must be concise. 0.85. What is the ratio of the Claims (% of GDP) of Sub-Saharan Africa (developing only) in 2004 to that in 2007?
Your answer should be compact. 0.91. What is the ratio of the Claims (% of GDP) in Dominican Republic in 2004 to that in 2007?
Give a very brief answer. 1.16. What is the ratio of the Claims (% of GDP) in Malaysia in 2004 to that in 2007?
Your answer should be very brief. 1.16. What is the ratio of the Claims (% of GDP) in St. Lucia in 2004 to that in 2007?
Offer a very short reply. 0.72. What is the ratio of the Claims (% of GDP) of Sub-Saharan Africa (developing only) in 2004 to that in 2008?
Keep it short and to the point. 1.09. What is the ratio of the Claims (% of GDP) of Dominican Republic in 2004 to that in 2008?
Offer a terse response. 1.15. What is the ratio of the Claims (% of GDP) of Malaysia in 2004 to that in 2008?
Keep it short and to the point. 1.19. What is the ratio of the Claims (% of GDP) in St. Lucia in 2004 to that in 2008?
Give a very brief answer. 0.66. What is the ratio of the Claims (% of GDP) of Sub-Saharan Africa (developing only) in 2004 to that in 2009?
Your answer should be compact. 0.96. What is the ratio of the Claims (% of GDP) in Dominican Republic in 2004 to that in 2009?
Your answer should be very brief. 1.12. What is the ratio of the Claims (% of GDP) of Malaysia in 2004 to that in 2009?
Your response must be concise. 1.04. What is the ratio of the Claims (% of GDP) of St. Lucia in 2004 to that in 2009?
Offer a very short reply. 0.64. What is the ratio of the Claims (% of GDP) in Sub-Saharan Africa (developing only) in 2005 to that in 2006?
Your answer should be very brief. 0.98. What is the ratio of the Claims (% of GDP) in Dominican Republic in 2005 to that in 2006?
Offer a very short reply. 1.04. What is the ratio of the Claims (% of GDP) in Malaysia in 2005 to that in 2006?
Your answer should be compact. 1.04. What is the ratio of the Claims (% of GDP) of St. Lucia in 2005 to that in 2006?
Your answer should be very brief. 0.93. What is the ratio of the Claims (% of GDP) in Sub-Saharan Africa (developing only) in 2005 to that in 2007?
Provide a succinct answer. 0.96. What is the ratio of the Claims (% of GDP) in Dominican Republic in 2005 to that in 2007?
Your answer should be compact. 1. What is the ratio of the Claims (% of GDP) of Malaysia in 2005 to that in 2007?
Offer a terse response. 1.08. What is the ratio of the Claims (% of GDP) in St. Lucia in 2005 to that in 2007?
Ensure brevity in your answer.  0.79. What is the ratio of the Claims (% of GDP) in Sub-Saharan Africa (developing only) in 2005 to that in 2008?
Keep it short and to the point. 1.14. What is the ratio of the Claims (% of GDP) of Dominican Republic in 2005 to that in 2008?
Offer a very short reply. 0.99. What is the ratio of the Claims (% of GDP) of Malaysia in 2005 to that in 2008?
Provide a succinct answer. 1.11. What is the ratio of the Claims (% of GDP) in St. Lucia in 2005 to that in 2008?
Offer a very short reply. 0.72. What is the ratio of the Claims (% of GDP) in Sub-Saharan Africa (developing only) in 2005 to that in 2009?
Make the answer very short. 1.01. What is the ratio of the Claims (% of GDP) in Dominican Republic in 2005 to that in 2009?
Keep it short and to the point. 0.97. What is the ratio of the Claims (% of GDP) of Malaysia in 2005 to that in 2009?
Keep it short and to the point. 0.97. What is the ratio of the Claims (% of GDP) of St. Lucia in 2005 to that in 2009?
Keep it short and to the point. 0.7. What is the ratio of the Claims (% of GDP) in Sub-Saharan Africa (developing only) in 2006 to that in 2007?
Provide a succinct answer. 0.97. What is the ratio of the Claims (% of GDP) in Dominican Republic in 2006 to that in 2007?
Give a very brief answer. 0.96. What is the ratio of the Claims (% of GDP) in Malaysia in 2006 to that in 2007?
Keep it short and to the point. 1.03. What is the ratio of the Claims (% of GDP) of St. Lucia in 2006 to that in 2007?
Your answer should be compact. 0.86. What is the ratio of the Claims (% of GDP) in Sub-Saharan Africa (developing only) in 2006 to that in 2008?
Make the answer very short. 1.16. What is the ratio of the Claims (% of GDP) in Dominican Republic in 2006 to that in 2008?
Make the answer very short. 0.95. What is the ratio of the Claims (% of GDP) in Malaysia in 2006 to that in 2008?
Your answer should be compact. 1.06. What is the ratio of the Claims (% of GDP) in St. Lucia in 2006 to that in 2008?
Ensure brevity in your answer.  0.78. What is the ratio of the Claims (% of GDP) of Sub-Saharan Africa (developing only) in 2006 to that in 2009?
Give a very brief answer. 1.03. What is the ratio of the Claims (% of GDP) in Dominican Republic in 2006 to that in 2009?
Provide a succinct answer. 0.93. What is the ratio of the Claims (% of GDP) of Malaysia in 2006 to that in 2009?
Your answer should be compact. 0.93. What is the ratio of the Claims (% of GDP) in St. Lucia in 2006 to that in 2009?
Provide a succinct answer. 0.76. What is the ratio of the Claims (% of GDP) in Sub-Saharan Africa (developing only) in 2007 to that in 2008?
Make the answer very short. 1.2. What is the ratio of the Claims (% of GDP) of Dominican Republic in 2007 to that in 2008?
Provide a succinct answer. 0.99. What is the ratio of the Claims (% of GDP) in Malaysia in 2007 to that in 2008?
Keep it short and to the point. 1.03. What is the ratio of the Claims (% of GDP) of St. Lucia in 2007 to that in 2008?
Your answer should be very brief. 0.91. What is the ratio of the Claims (% of GDP) in Sub-Saharan Africa (developing only) in 2007 to that in 2009?
Provide a succinct answer. 1.06. What is the ratio of the Claims (% of GDP) of Dominican Republic in 2007 to that in 2009?
Give a very brief answer. 0.97. What is the ratio of the Claims (% of GDP) in Malaysia in 2007 to that in 2009?
Your answer should be very brief. 0.9. What is the ratio of the Claims (% of GDP) in St. Lucia in 2007 to that in 2009?
Give a very brief answer. 0.88. What is the ratio of the Claims (% of GDP) in Sub-Saharan Africa (developing only) in 2008 to that in 2009?
Give a very brief answer. 0.88. What is the ratio of the Claims (% of GDP) in Dominican Republic in 2008 to that in 2009?
Give a very brief answer. 0.97. What is the ratio of the Claims (% of GDP) in Malaysia in 2008 to that in 2009?
Offer a very short reply. 0.87. What is the ratio of the Claims (% of GDP) in St. Lucia in 2008 to that in 2009?
Offer a very short reply. 0.97. What is the difference between the highest and the second highest Claims (% of GDP) in Sub-Saharan Africa (developing only)?
Ensure brevity in your answer.  2.25. What is the difference between the highest and the second highest Claims (% of GDP) of Dominican Republic?
Your answer should be very brief. 3.61. What is the difference between the highest and the second highest Claims (% of GDP) of Malaysia?
Provide a short and direct response. 5.12. What is the difference between the highest and the second highest Claims (% of GDP) of St. Lucia?
Offer a terse response. 3.58. What is the difference between the highest and the lowest Claims (% of GDP) in Sub-Saharan Africa (developing only)?
Provide a short and direct response. 23.72. What is the difference between the highest and the lowest Claims (% of GDP) of Dominican Republic?
Your answer should be compact. 18.13. What is the difference between the highest and the lowest Claims (% of GDP) in Malaysia?
Make the answer very short. 36.14. What is the difference between the highest and the lowest Claims (% of GDP) of St. Lucia?
Your answer should be very brief. 41.9. 